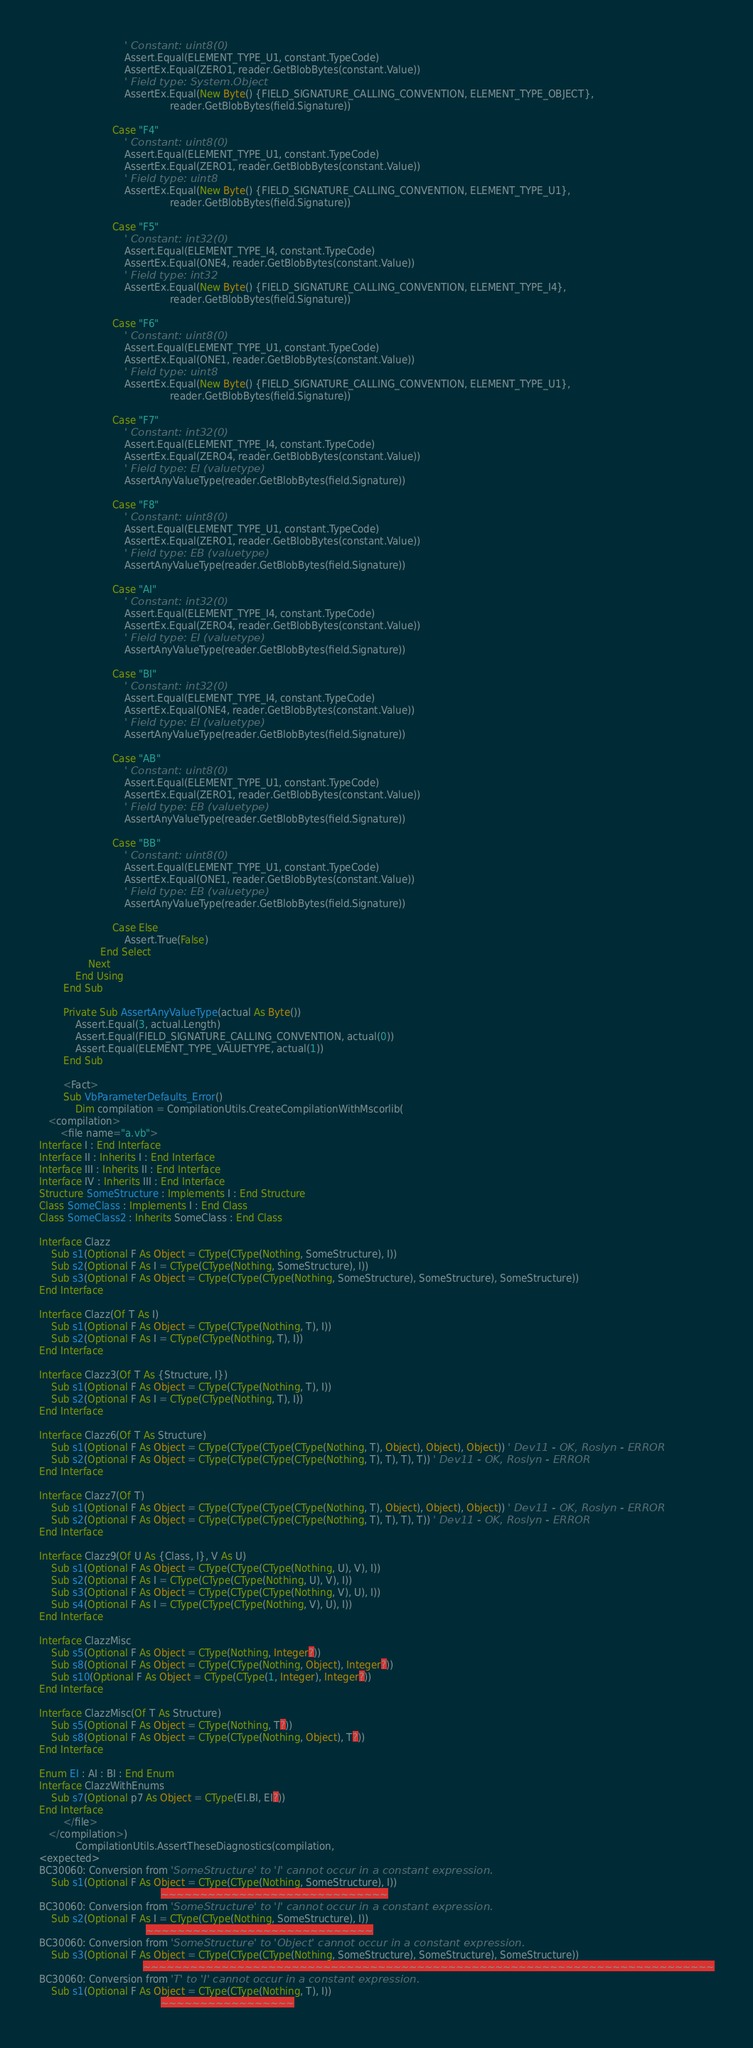<code> <loc_0><loc_0><loc_500><loc_500><_VisualBasic_>                            ' Constant: uint8(0)
                            Assert.Equal(ELEMENT_TYPE_U1, constant.TypeCode)
                            AssertEx.Equal(ZERO1, reader.GetBlobBytes(constant.Value))
                            ' Field type: System.Object
                            AssertEx.Equal(New Byte() {FIELD_SIGNATURE_CALLING_CONVENTION, ELEMENT_TYPE_OBJECT},
                                           reader.GetBlobBytes(field.Signature))

                        Case "F4"
                            ' Constant: uint8(0)
                            Assert.Equal(ELEMENT_TYPE_U1, constant.TypeCode)
                            AssertEx.Equal(ZERO1, reader.GetBlobBytes(constant.Value))
                            ' Field type: uint8
                            AssertEx.Equal(New Byte() {FIELD_SIGNATURE_CALLING_CONVENTION, ELEMENT_TYPE_U1},
                                           reader.GetBlobBytes(field.Signature))

                        Case "F5"
                            ' Constant: int32(0)
                            Assert.Equal(ELEMENT_TYPE_I4, constant.TypeCode)
                            AssertEx.Equal(ONE4, reader.GetBlobBytes(constant.Value))
                            ' Field type: int32
                            AssertEx.Equal(New Byte() {FIELD_SIGNATURE_CALLING_CONVENTION, ELEMENT_TYPE_I4},
                                           reader.GetBlobBytes(field.Signature))

                        Case "F6"
                            ' Constant: uint8(0)
                            Assert.Equal(ELEMENT_TYPE_U1, constant.TypeCode)
                            AssertEx.Equal(ONE1, reader.GetBlobBytes(constant.Value))
                            ' Field type: uint8
                            AssertEx.Equal(New Byte() {FIELD_SIGNATURE_CALLING_CONVENTION, ELEMENT_TYPE_U1},
                                           reader.GetBlobBytes(field.Signature))

                        Case "F7"
                            ' Constant: int32(0)
                            Assert.Equal(ELEMENT_TYPE_I4, constant.TypeCode)
                            AssertEx.Equal(ZERO4, reader.GetBlobBytes(constant.Value))
                            ' Field type: EI (valuetype)
                            AssertAnyValueType(reader.GetBlobBytes(field.Signature))

                        Case "F8"
                            ' Constant: uint8(0)
                            Assert.Equal(ELEMENT_TYPE_U1, constant.TypeCode)
                            AssertEx.Equal(ZERO1, reader.GetBlobBytes(constant.Value))
                            ' Field type: EB (valuetype)
                            AssertAnyValueType(reader.GetBlobBytes(field.Signature))

                        Case "AI"
                            ' Constant: int32(0)
                            Assert.Equal(ELEMENT_TYPE_I4, constant.TypeCode)
                            AssertEx.Equal(ZERO4, reader.GetBlobBytes(constant.Value))
                            ' Field type: EI (valuetype)
                            AssertAnyValueType(reader.GetBlobBytes(field.Signature))

                        Case "BI"
                            ' Constant: int32(0)
                            Assert.Equal(ELEMENT_TYPE_I4, constant.TypeCode)
                            AssertEx.Equal(ONE4, reader.GetBlobBytes(constant.Value))
                            ' Field type: EI (valuetype)
                            AssertAnyValueType(reader.GetBlobBytes(field.Signature))

                        Case "AB"
                            ' Constant: uint8(0)
                            Assert.Equal(ELEMENT_TYPE_U1, constant.TypeCode)
                            AssertEx.Equal(ZERO1, reader.GetBlobBytes(constant.Value))
                            ' Field type: EB (valuetype)
                            AssertAnyValueType(reader.GetBlobBytes(field.Signature))

                        Case "BB"
                            ' Constant: uint8(0)
                            Assert.Equal(ELEMENT_TYPE_U1, constant.TypeCode)
                            AssertEx.Equal(ONE1, reader.GetBlobBytes(constant.Value))
                            ' Field type: EB (valuetype)
                            AssertAnyValueType(reader.GetBlobBytes(field.Signature))

                        Case Else
                            Assert.True(False)
                    End Select
                Next
            End Using
        End Sub

        Private Sub AssertAnyValueType(actual As Byte())
            Assert.Equal(3, actual.Length)
            Assert.Equal(FIELD_SIGNATURE_CALLING_CONVENTION, actual(0))
            Assert.Equal(ELEMENT_TYPE_VALUETYPE, actual(1))
        End Sub

        <Fact>
        Sub VbParameterDefaults_Error()
            Dim compilation = CompilationUtils.CreateCompilationWithMscorlib(
   <compilation>
       <file name="a.vb">
Interface I : End Interface
Interface II : Inherits I : End Interface
Interface III : Inherits II : End Interface
Interface IV : Inherits III : End Interface
Structure SomeStructure : Implements I : End Structure
Class SomeClass : Implements I : End Class
Class SomeClass2 : Inherits SomeClass : End Class

Interface Clazz
    Sub s1(Optional F As Object = CType(CType(Nothing, SomeStructure), I))
    Sub s2(Optional F As I = CType(CType(Nothing, SomeStructure), I))
    Sub s3(Optional F As Object = CType(CType(CType(Nothing, SomeStructure), SomeStructure), SomeStructure))
End Interface

Interface Clazz(Of T As I)
    Sub s1(Optional F As Object = CType(CType(Nothing, T), I))
    Sub s2(Optional F As I = CType(CType(Nothing, T), I))
End Interface

Interface Clazz3(Of T As {Structure, I})
    Sub s1(Optional F As Object = CType(CType(Nothing, T), I))
    Sub s2(Optional F As I = CType(CType(Nothing, T), I))
End Interface

Interface Clazz6(Of T As Structure)
    Sub s1(Optional F As Object = CType(CType(CType(CType(Nothing, T), Object), Object), Object)) ' Dev11 - OK, Roslyn - ERROR
    Sub s2(Optional F As Object = CType(CType(CType(CType(Nothing, T), T), T), T)) ' Dev11 - OK, Roslyn - ERROR
End Interface

Interface Clazz7(Of T)
    Sub s1(Optional F As Object = CType(CType(CType(CType(Nothing, T), Object), Object), Object)) ' Dev11 - OK, Roslyn - ERROR
    Sub s2(Optional F As Object = CType(CType(CType(CType(Nothing, T), T), T), T)) ' Dev11 - OK, Roslyn - ERROR
End Interface

Interface Clazz9(Of U As {Class, I}, V As U)
    Sub s1(Optional F As Object = CType(CType(CType(Nothing, U), V), I))
    Sub s2(Optional F As I = CType(CType(CType(Nothing, U), V), I))
    Sub s3(Optional F As Object = CType(CType(CType(Nothing, V), U), I))
    Sub s4(Optional F As I = CType(CType(CType(Nothing, V), U), I))
End Interface

Interface ClazzMisc
    Sub s5(Optional F As Object = CType(Nothing, Integer?))
    Sub s8(Optional F As Object = CType(CType(Nothing, Object), Integer?))
    Sub s10(Optional F As Object = CType(CType(1, Integer), Integer?))
End Interface

Interface ClazzMisc(Of T As Structure)
    Sub s5(Optional F As Object = CType(Nothing, T?))
    Sub s8(Optional F As Object = CType(CType(Nothing, Object), T?))
End Interface

Enum EI : AI : BI : End Enum
Interface ClazzWithEnums
    Sub s7(Optional p7 As Object = CType(EI.BI, EI?))
End Interface
        </file>
   </compilation>)
            CompilationUtils.AssertTheseDiagnostics(compilation,
<expected>
BC30060: Conversion from 'SomeStructure' to 'I' cannot occur in a constant expression.
    Sub s1(Optional F As Object = CType(CType(Nothing, SomeStructure), I))
                                        ~~~~~~~~~~~~~~~~~~~~~~~~~~~~~
BC30060: Conversion from 'SomeStructure' to 'I' cannot occur in a constant expression.
    Sub s2(Optional F As I = CType(CType(Nothing, SomeStructure), I))
                                   ~~~~~~~~~~~~~~~~~~~~~~~~~~~~~
BC30060: Conversion from 'SomeStructure' to 'Object' cannot occur in a constant expression.
    Sub s3(Optional F As Object = CType(CType(CType(Nothing, SomeStructure), SomeStructure), SomeStructure))
                                  ~~~~~~~~~~~~~~~~~~~~~~~~~~~~~~~~~~~~~~~~~~~~~~~~~~~~~~~~~~~~~~~~~~~~~~~~~
BC30060: Conversion from 'T' to 'I' cannot occur in a constant expression.
    Sub s1(Optional F As Object = CType(CType(Nothing, T), I))
                                        ~~~~~~~~~~~~~~~~~</code> 